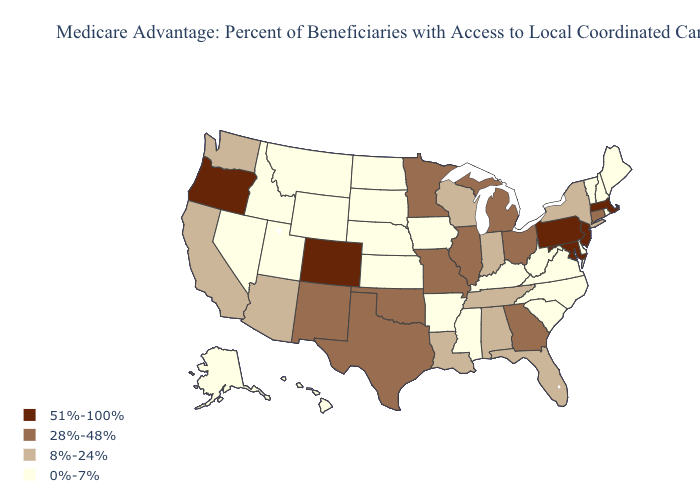Does the first symbol in the legend represent the smallest category?
Be succinct. No. Does New Jersey have a higher value than Maryland?
Concise answer only. No. What is the value of Colorado?
Quick response, please. 51%-100%. Does New Mexico have the lowest value in the West?
Quick response, please. No. Name the states that have a value in the range 8%-24%?
Give a very brief answer. Alabama, Arizona, California, Florida, Indiana, Louisiana, New York, Tennessee, Washington, Wisconsin. Which states have the lowest value in the USA?
Concise answer only. Alaska, Arkansas, Delaware, Hawaii, Iowa, Idaho, Kansas, Kentucky, Maine, Mississippi, Montana, North Carolina, North Dakota, Nebraska, New Hampshire, Nevada, Rhode Island, South Carolina, South Dakota, Utah, Virginia, Vermont, West Virginia, Wyoming. Does Colorado have the highest value in the West?
Answer briefly. Yes. What is the lowest value in the USA?
Short answer required. 0%-7%. Does the map have missing data?
Be succinct. No. Does Rhode Island have the highest value in the USA?
Quick response, please. No. Name the states that have a value in the range 28%-48%?
Keep it brief. Connecticut, Georgia, Illinois, Michigan, Minnesota, Missouri, New Mexico, Ohio, Oklahoma, Texas. Which states have the lowest value in the USA?
Give a very brief answer. Alaska, Arkansas, Delaware, Hawaii, Iowa, Idaho, Kansas, Kentucky, Maine, Mississippi, Montana, North Carolina, North Dakota, Nebraska, New Hampshire, Nevada, Rhode Island, South Carolina, South Dakota, Utah, Virginia, Vermont, West Virginia, Wyoming. Name the states that have a value in the range 28%-48%?
Write a very short answer. Connecticut, Georgia, Illinois, Michigan, Minnesota, Missouri, New Mexico, Ohio, Oklahoma, Texas. What is the highest value in the USA?
Write a very short answer. 51%-100%. 